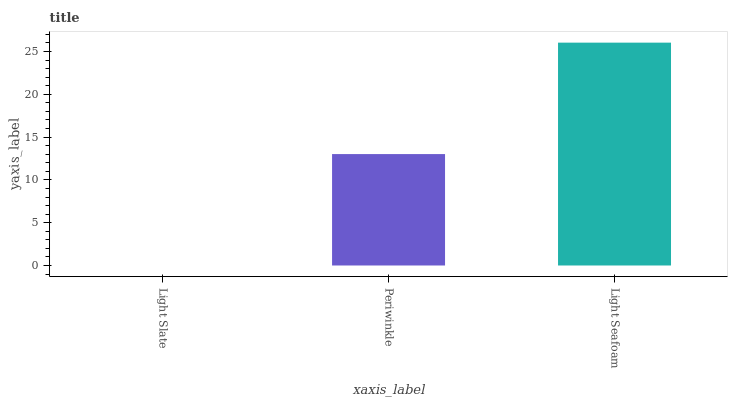Is Light Slate the minimum?
Answer yes or no. Yes. Is Light Seafoam the maximum?
Answer yes or no. Yes. Is Periwinkle the minimum?
Answer yes or no. No. Is Periwinkle the maximum?
Answer yes or no. No. Is Periwinkle greater than Light Slate?
Answer yes or no. Yes. Is Light Slate less than Periwinkle?
Answer yes or no. Yes. Is Light Slate greater than Periwinkle?
Answer yes or no. No. Is Periwinkle less than Light Slate?
Answer yes or no. No. Is Periwinkle the high median?
Answer yes or no. Yes. Is Periwinkle the low median?
Answer yes or no. Yes. Is Light Slate the high median?
Answer yes or no. No. Is Light Slate the low median?
Answer yes or no. No. 